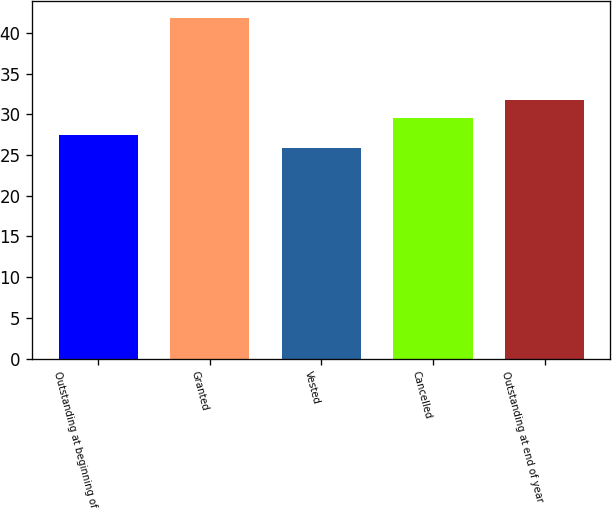<chart> <loc_0><loc_0><loc_500><loc_500><bar_chart><fcel>Outstanding at beginning of<fcel>Granted<fcel>Vested<fcel>Cancelled<fcel>Outstanding at end of year<nl><fcel>27.4<fcel>41.82<fcel>25.8<fcel>29.56<fcel>31.77<nl></chart> 